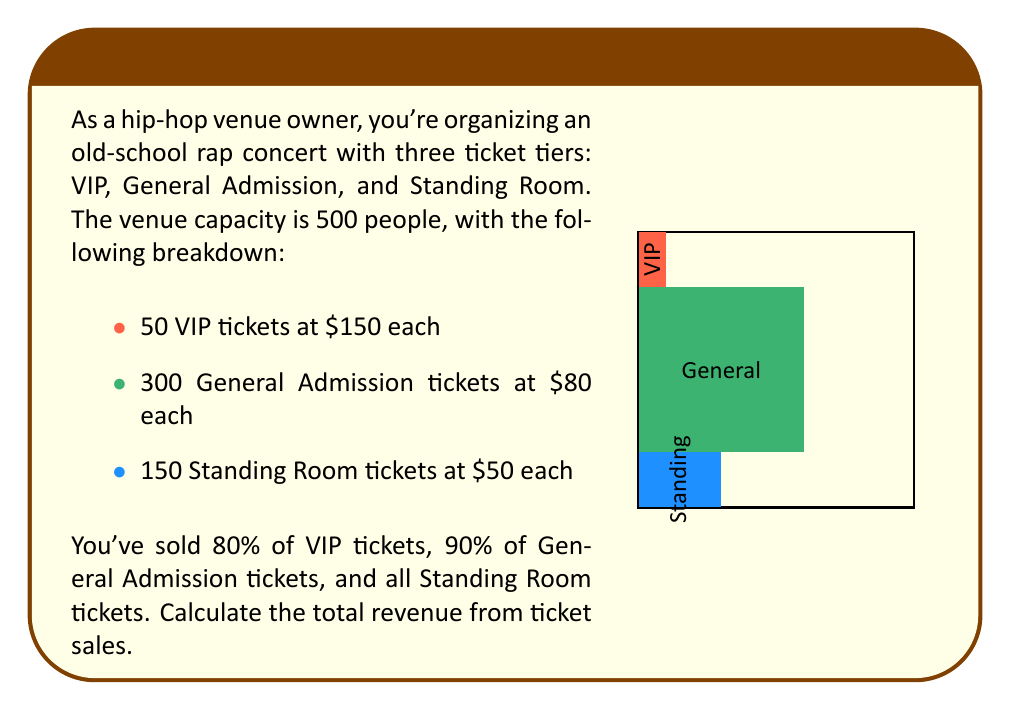Teach me how to tackle this problem. Let's break this down step-by-step:

1. Calculate the number of tickets sold for each tier:
   - VIP: $50 \times 80\% = 50 \times 0.8 = 40$ tickets
   - General Admission: $300 \times 90\% = 300 \times 0.9 = 270$ tickets
   - Standing Room: $150 \times 100\% = 150$ tickets

2. Calculate the revenue for each tier:
   - VIP Revenue: $40 \times \$150 = \$6,000$
   - General Admission Revenue: $270 \times \$80 = \$21,600$
   - Standing Room Revenue: $150 \times \$50 = \$7,500$

3. Sum up the total revenue:
   $$\text{Total Revenue} = \$6,000 + \$21,600 + \$7,500 = \$35,100$$

Therefore, the total revenue from ticket sales is $\$35,100$.
Answer: $35,100 